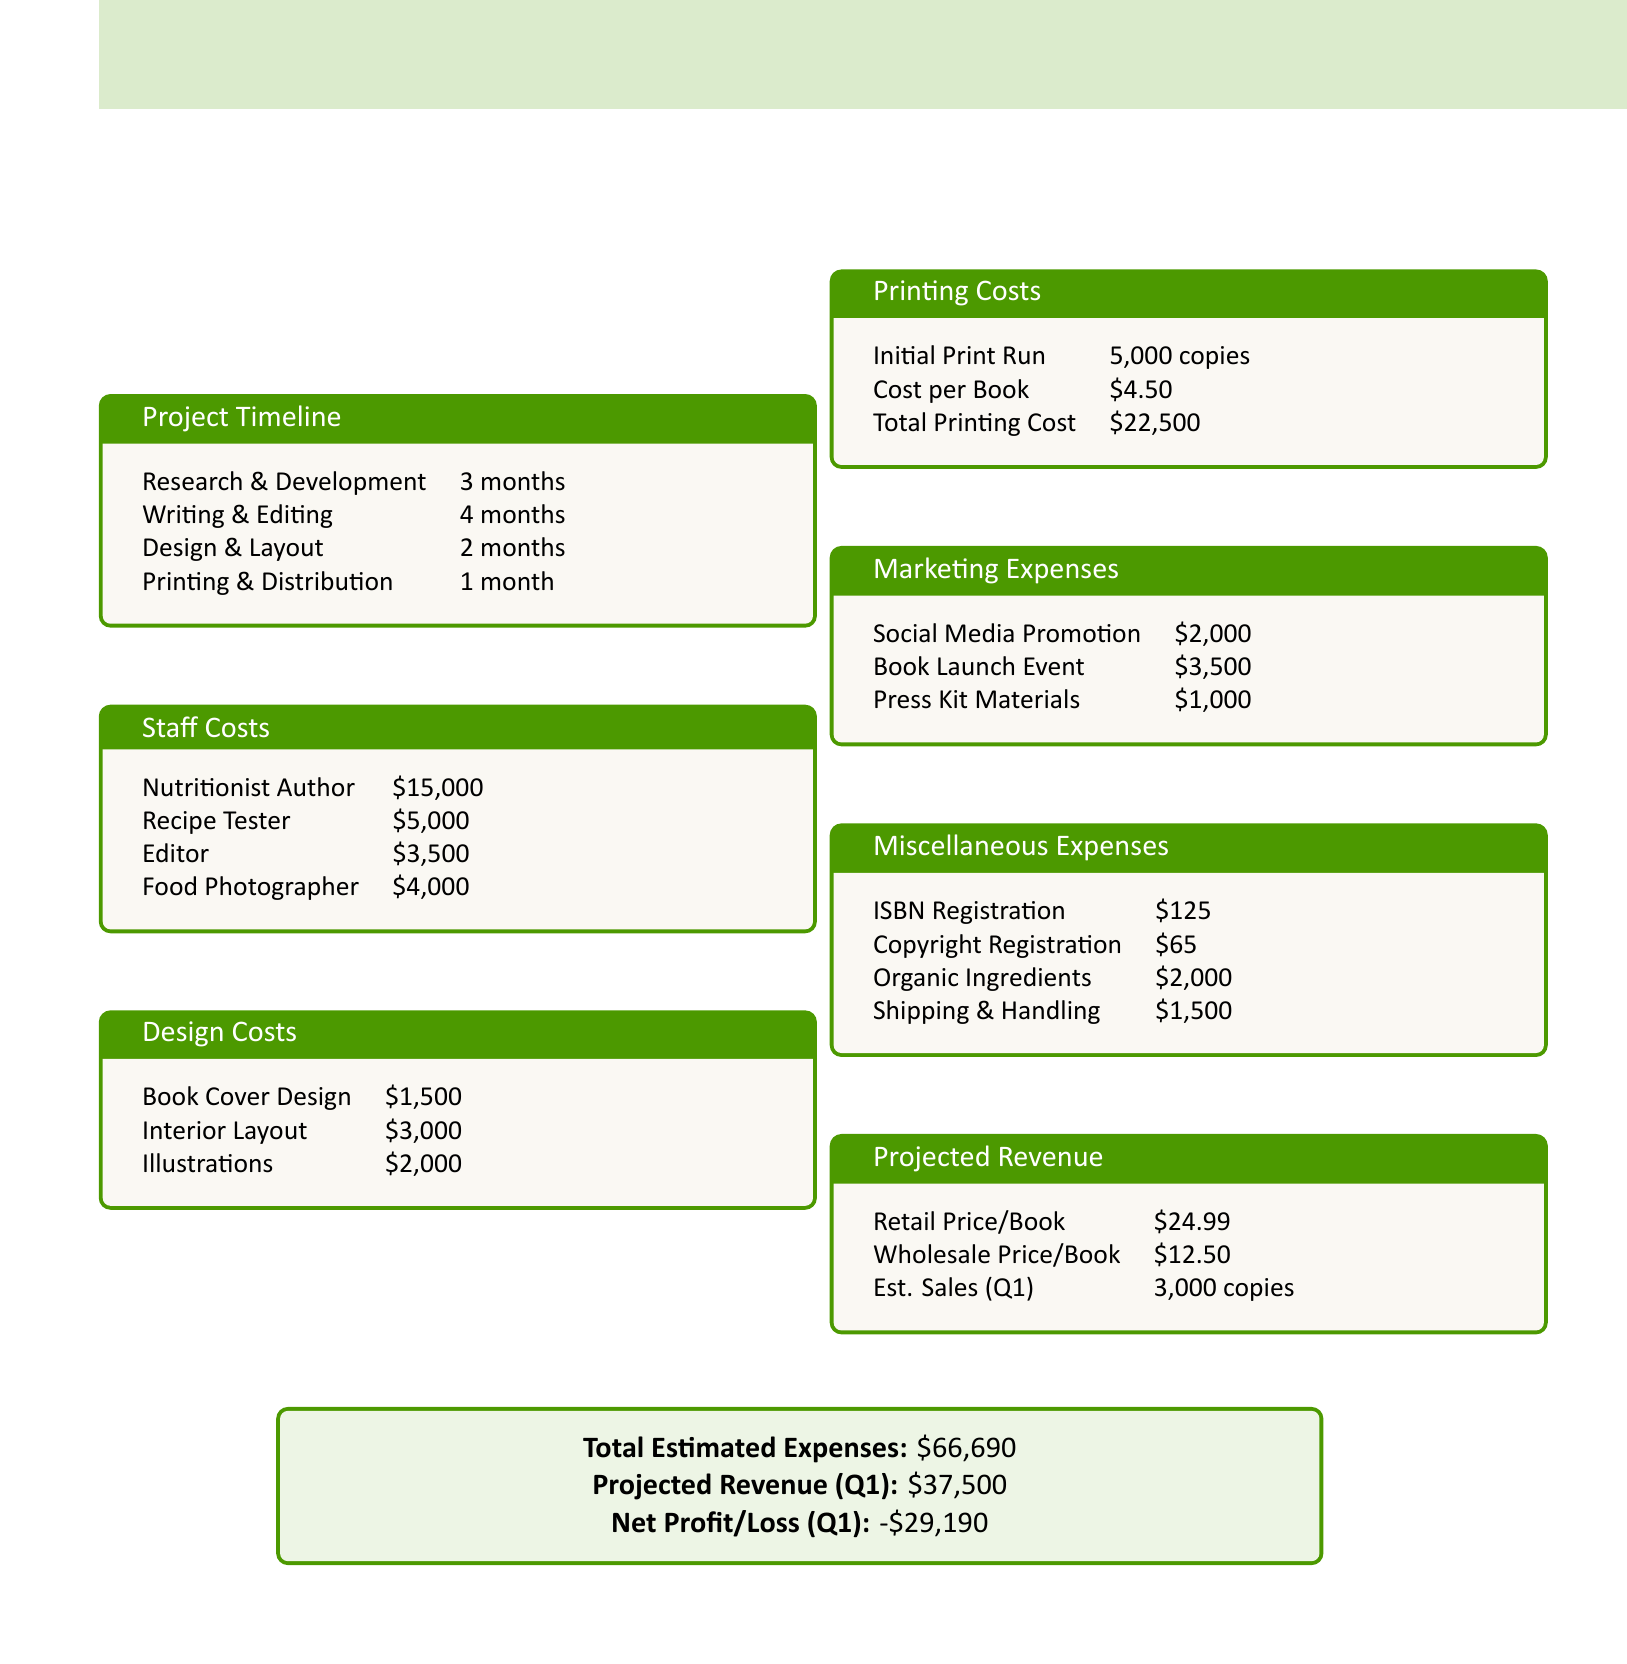What is the total estimated expenses? The total estimated expenses are listed in the document and calculated as the sum of all expenses, which amounts to $66,690.
Answer: $66,690 How much does the nutritionist author get paid? The document specifies the staff costs and notes that the nutritionist author is paid $15,000.
Answer: $15,000 What is the cost per book for printing? The document indicates that the cost per book for printing is $4.50.
Answer: $4.50 How long is the writing and editing phase? The project timeline in the document states that the writing and editing phase lasts for 4 months.
Answer: 4 months What are the marketing expenses for the book launch event? The document lists the marketing expenses and states that the cost for the book launch event is $3,500.
Answer: $3,500 What is the initial print run for the cookbook? The printing costs section of the document specifies that the initial print run is 5,000 copies.
Answer: 5,000 copies How much is allocated for organic ingredients? The miscellaneous expenses categorized in the document show that $2,000 is allocated for organic ingredients.
Answer: $2,000 What is the net profit/loss for Q1? The document summarizes the financial outcomes, indicating a net profit/loss of -$29,190 for Q1.
Answer: -$29,190 What is the projected revenue from estimated sales in Q1? The document provides estimated sales of 3,000 copies at a retail price, leading to a projected revenue of $37,500 for Q1.
Answer: $37,500 